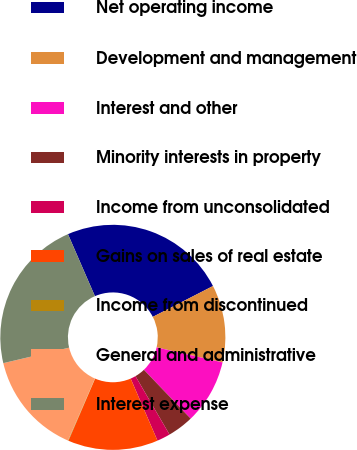Convert chart. <chart><loc_0><loc_0><loc_500><loc_500><pie_chart><fcel>Net operating income<fcel>Development and management<fcel>Interest and other<fcel>Minority interests in property<fcel>Income from unconsolidated<fcel>Gains on sales of real estate<fcel>Income from discontinued<fcel>General and administrative<fcel>Interest expense<nl><fcel>23.99%<fcel>11.11%<fcel>9.27%<fcel>3.75%<fcel>1.91%<fcel>12.95%<fcel>0.07%<fcel>14.79%<fcel>22.15%<nl></chart> 